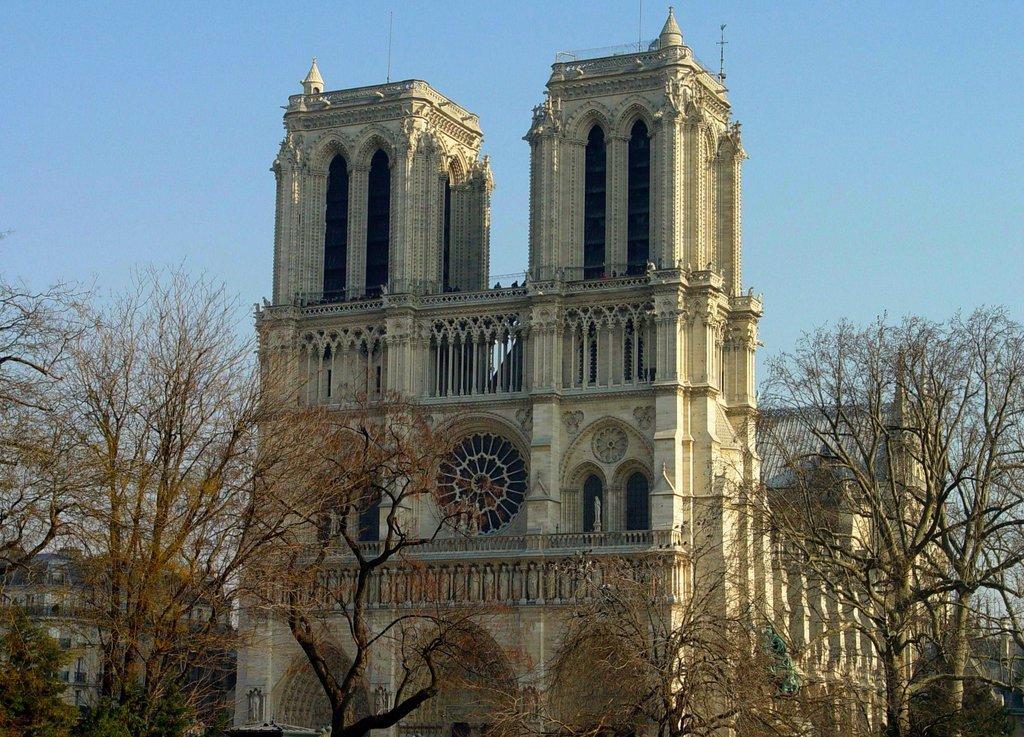Can you describe this image briefly? In the image there is a building in the back with trees in front of it and above its sky. 